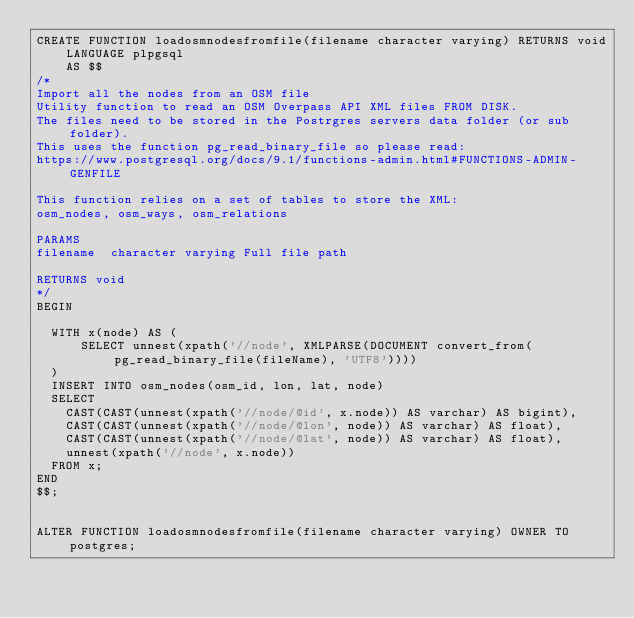Convert code to text. <code><loc_0><loc_0><loc_500><loc_500><_SQL_>CREATE FUNCTION loadosmnodesfromfile(filename character varying) RETURNS void
    LANGUAGE plpgsql
    AS $$
/*
Import all the nodes from an OSM file
Utility function to read an OSM Overpass API XML files FROM DISK.
The files need to be stored in the Postrgres servers data folder (or sub folder).
This uses the function pg_read_binary_file so please read: 
https://www.postgresql.org/docs/9.1/functions-admin.html#FUNCTIONS-ADMIN-GENFILE

This function relies on a set of tables to store the XML:
osm_nodes, osm_ways, osm_relations

PARAMS
filename	character varying	Full file path 

RETURNS void
*/
BEGIN

	WITH x(node) AS (
	    SELECT unnest(xpath('//node', XMLPARSE(DOCUMENT convert_from(pg_read_binary_file(fileName), 'UTF8'))))
	) 
	INSERT INTO osm_nodes(osm_id, lon, lat, node)
	SELECT
		CAST(CAST(unnest(xpath('//node/@id', x.node)) AS varchar) AS bigint),
		CAST(CAST(unnest(xpath('//node/@lon', node)) AS varchar) AS float),
		CAST(CAST(unnest(xpath('//node/@lat', node)) AS varchar) AS float),
		unnest(xpath('//node', x.node))
	FROM x;
END
$$;


ALTER FUNCTION loadosmnodesfromfile(filename character varying) OWNER TO postgres;</code> 